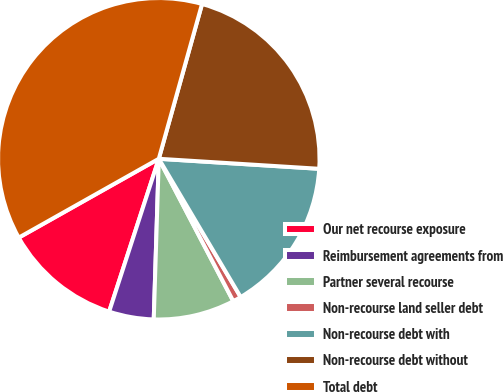Convert chart to OTSL. <chart><loc_0><loc_0><loc_500><loc_500><pie_chart><fcel>Our net recourse exposure<fcel>Reimbursement agreements from<fcel>Partner several recourse<fcel>Non-recourse land seller debt<fcel>Non-recourse debt with<fcel>Non-recourse debt without<fcel>Total debt<nl><fcel>11.84%<fcel>4.5%<fcel>8.17%<fcel>0.84%<fcel>15.5%<fcel>21.66%<fcel>37.5%<nl></chart> 